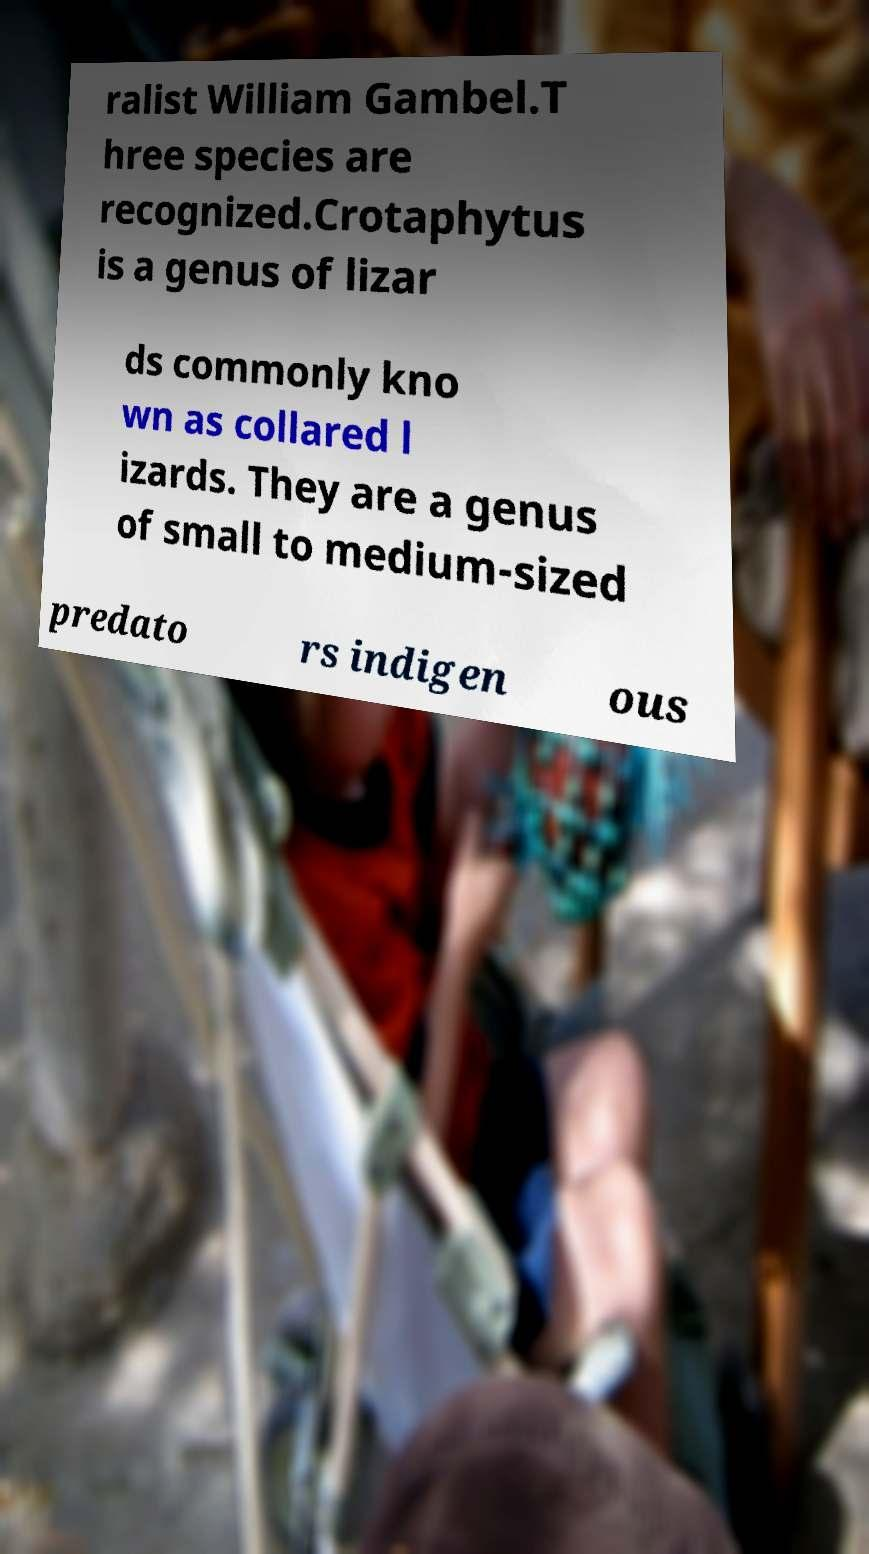There's text embedded in this image that I need extracted. Can you transcribe it verbatim? ralist William Gambel.T hree species are recognized.Crotaphytus is a genus of lizar ds commonly kno wn as collared l izards. They are a genus of small to medium-sized predato rs indigen ous 